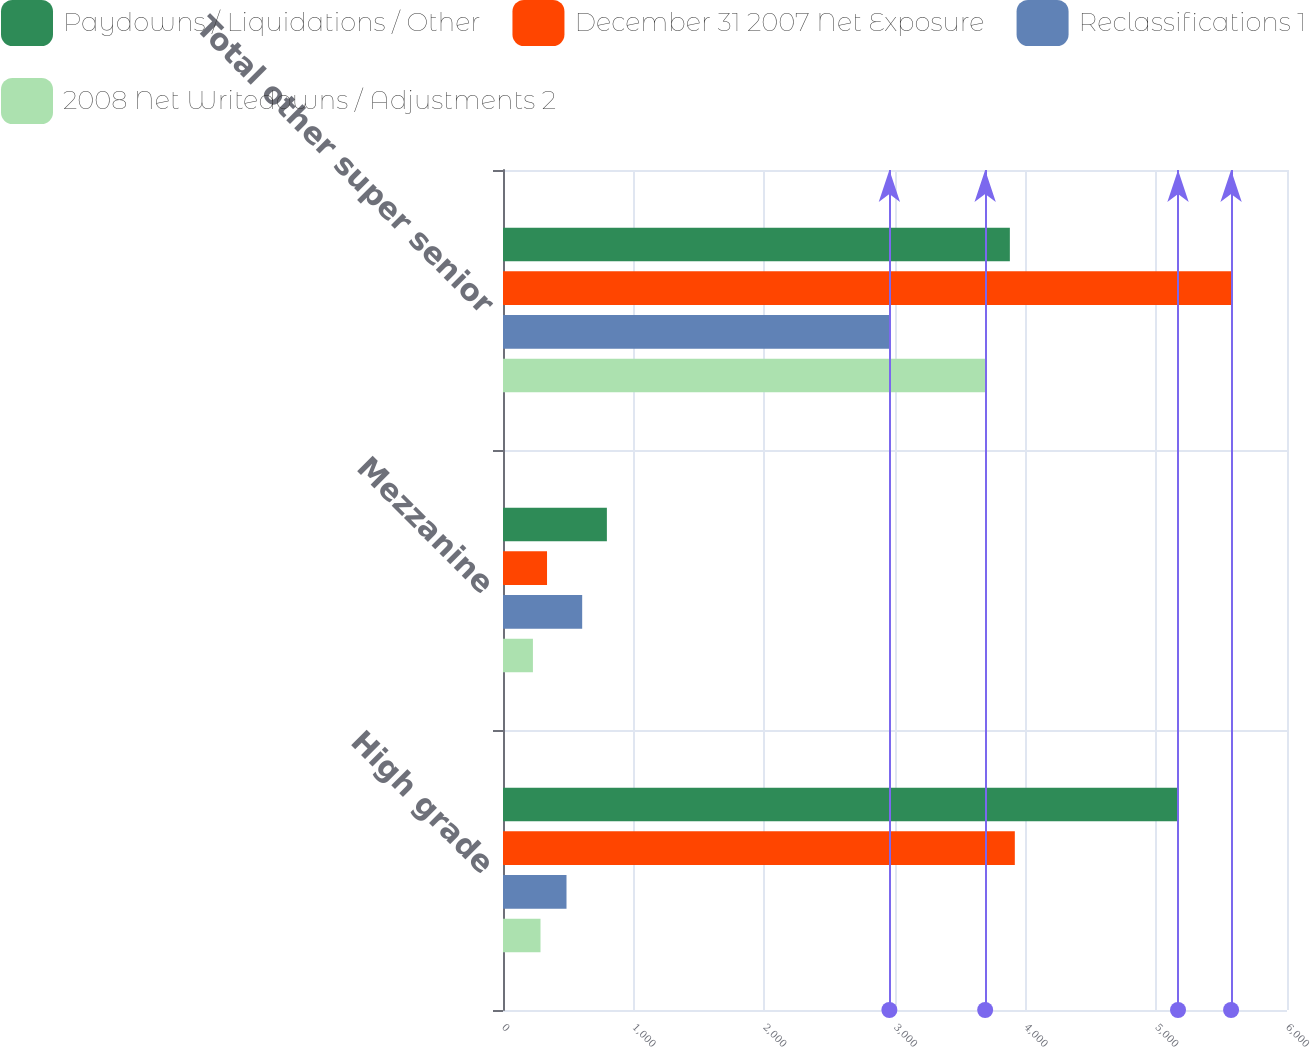Convert chart. <chart><loc_0><loc_0><loc_500><loc_500><stacked_bar_chart><ecel><fcel>High grade<fcel>Mezzanine<fcel>Total other super senior<nl><fcel>Paydowns / Liquidations / Other<fcel>5166<fcel>795<fcel>3879<nl><fcel>December 31 2007 Net Exposure<fcel>3917<fcel>337<fcel>5572<nl><fcel>Reclassifications 1<fcel>486<fcel>606<fcel>2957<nl><fcel>2008 Net Writedowns / Adjustments 2<fcel>287<fcel>229<fcel>3690<nl></chart> 